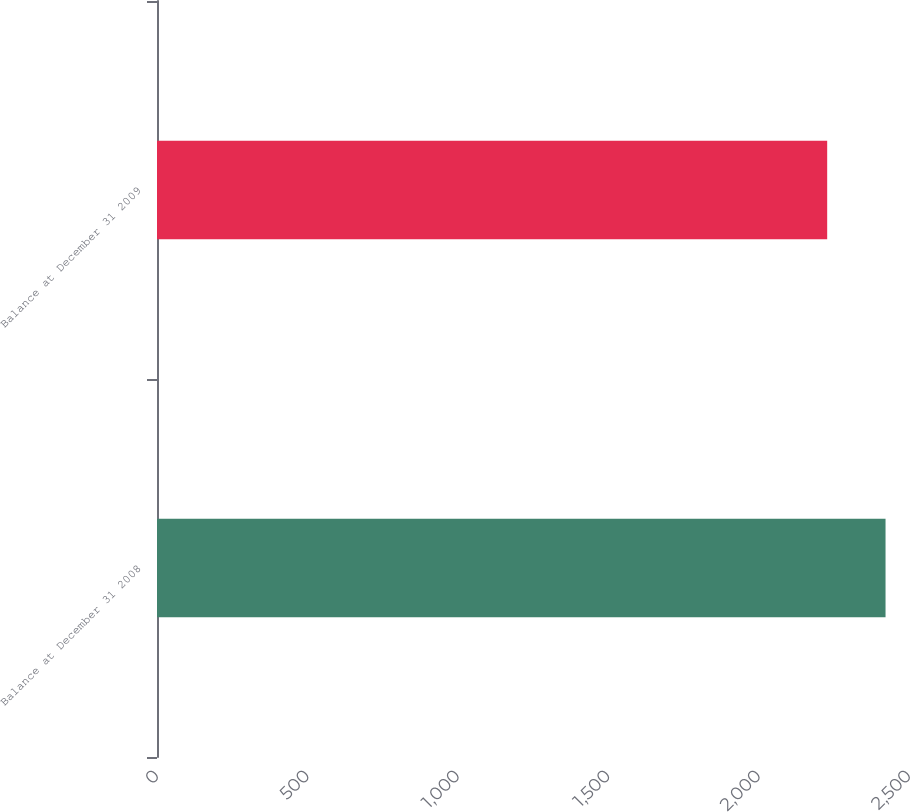Convert chart to OTSL. <chart><loc_0><loc_0><loc_500><loc_500><bar_chart><fcel>Balance at December 31 2008<fcel>Balance at December 31 2009<nl><fcel>2422<fcel>2228<nl></chart> 